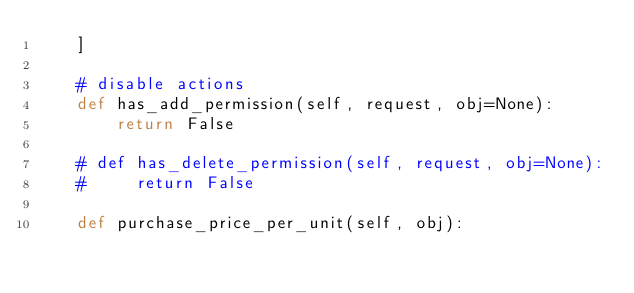Convert code to text. <code><loc_0><loc_0><loc_500><loc_500><_Python_>    ]

    # disable actions
    def has_add_permission(self, request, obj=None):
        return False

    # def has_delete_permission(self, request, obj=None):
    #     return False

    def purchase_price_per_unit(self, obj):</code> 